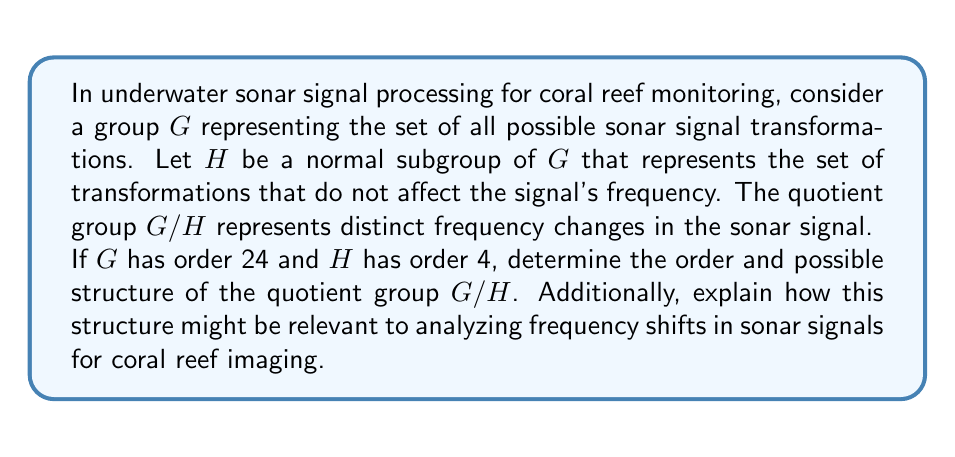Can you answer this question? To solve this problem, we'll follow these steps:

1) First, recall the Lagrange's theorem, which states that for a finite group $G$ and a subgroup $H$ of $G$, the order of $H$ divides the order of $G$. Moreover, the order of the quotient group $G/H$ is equal to the index of $H$ in $G$, which is $|G|/|H|$.

2) Given:
   $|G| = 24$
   $|H| = 4$

3) Calculate the order of $G/H$:
   $$|G/H| = |G| / |H| = 24 / 4 = 6$$

4) Now, we need to determine the possible structure of a group of order 6. There are two possibilities:
   a) Cyclic group $C_6$
   b) Symmetric group $S_3$

5) To differentiate between these, we need more information about $G$ and $H$. However, both structures have relevance in signal processing:

   - If $G/H \cong C_6$, it suggests that the frequency changes occur in a cyclic manner, with 6 distinct stages that eventually return to the original state.
   
   - If $G/H \cong S_3$, it implies that the frequency changes have more complex interactions, potentially involving permutations of three fundamental frequency states.

6) In the context of coral reef imaging:
   - The cyclic structure ($C_6$) could represent periodic frequency shifts due to regular environmental factors like tides or diurnal cycles.
   - The symmetric group structure ($S_3$) might indicate more complex frequency interactions, possibly related to varying depths, reef structures, or marine life interactions.

Either structure provides a framework for categorizing and analyzing frequency changes in sonar signals, which is crucial for accurate underwater imaging and long-term monitoring of coral reefs.
Answer: The order of the quotient group $G/H$ is 6. The possible structures are either the cyclic group $C_6$ or the symmetric group $S_3$, depending on the specific properties of $G$ and $H$. Both structures have relevant interpretations in sonar signal processing for coral reef monitoring. 